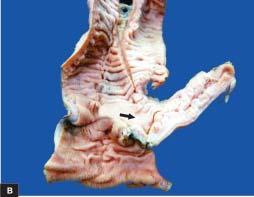does the centres of whorls of smooth muscle and connective tissue contain necrotic debris?
Answer the question using a single word or phrase. No 